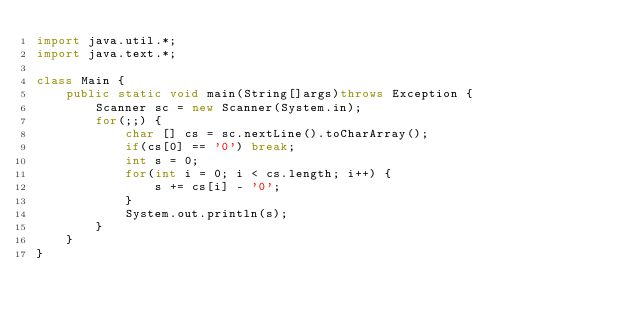<code> <loc_0><loc_0><loc_500><loc_500><_Java_>import java.util.*;
import java.text.*;

class Main {
    public static void main(String[]args)throws Exception {
        Scanner sc = new Scanner(System.in);
        for(;;) {
            char [] cs = sc.nextLine().toCharArray();
            if(cs[0] == '0') break;
            int s = 0;
            for(int i = 0; i < cs.length; i++) {
                s += cs[i] - '0';
            }
            System.out.println(s);
        }
    }
}</code> 